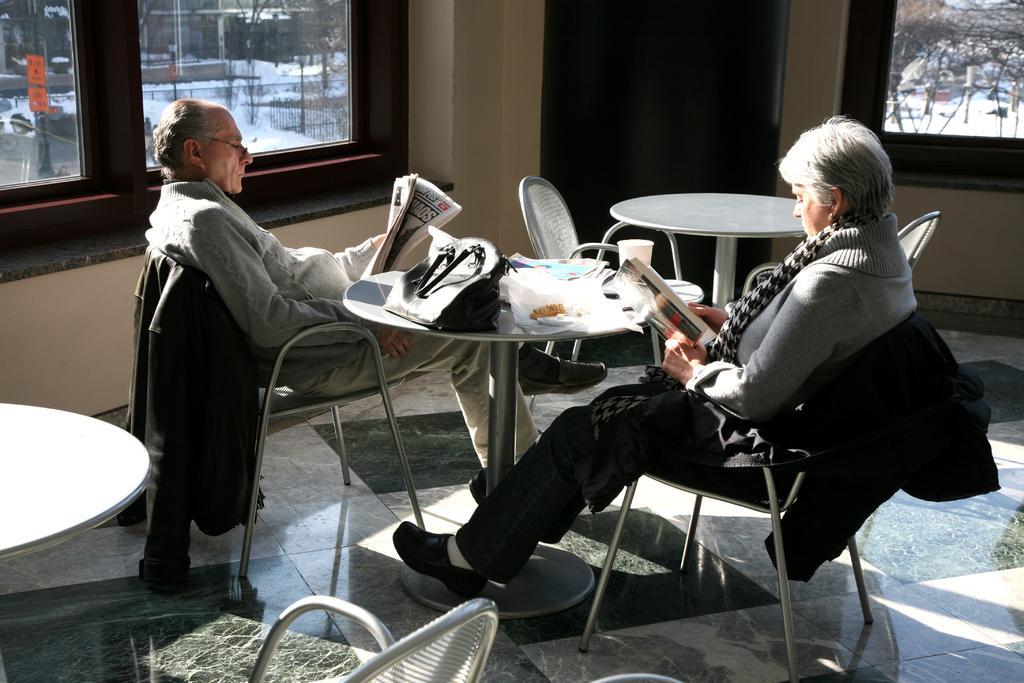In one or two sentences, can you explain what this image depicts? there are two persons sitting on chairs. A man is reading newspaper wearing specs. A lady is wearing scarf and holding a book. There are many tables chairs. On the table there is a handbag and some other items also a cup. In the background there is a window wall. 